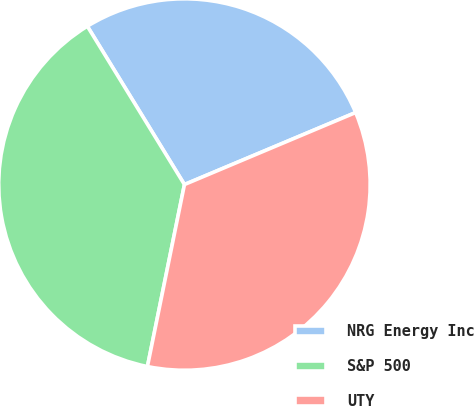Convert chart. <chart><loc_0><loc_0><loc_500><loc_500><pie_chart><fcel>NRG Energy Inc<fcel>S&P 500<fcel>UTY<nl><fcel>27.42%<fcel>38.05%<fcel>34.53%<nl></chart> 